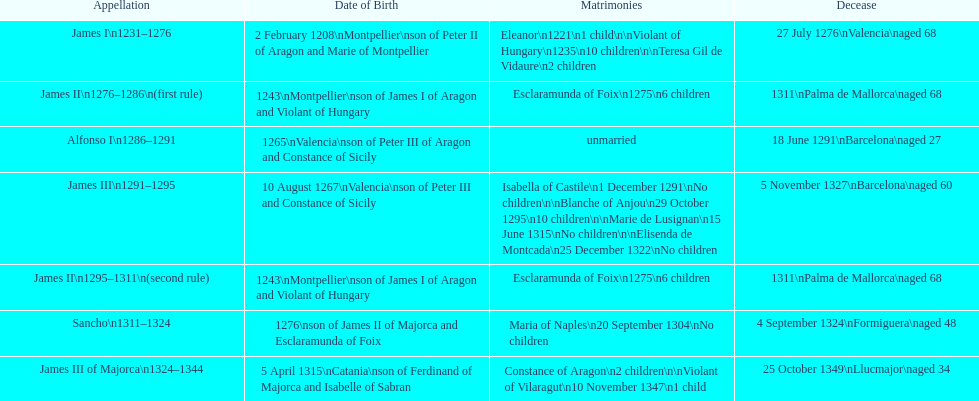Was james iii or sancho born in the year 1276? Sancho. 